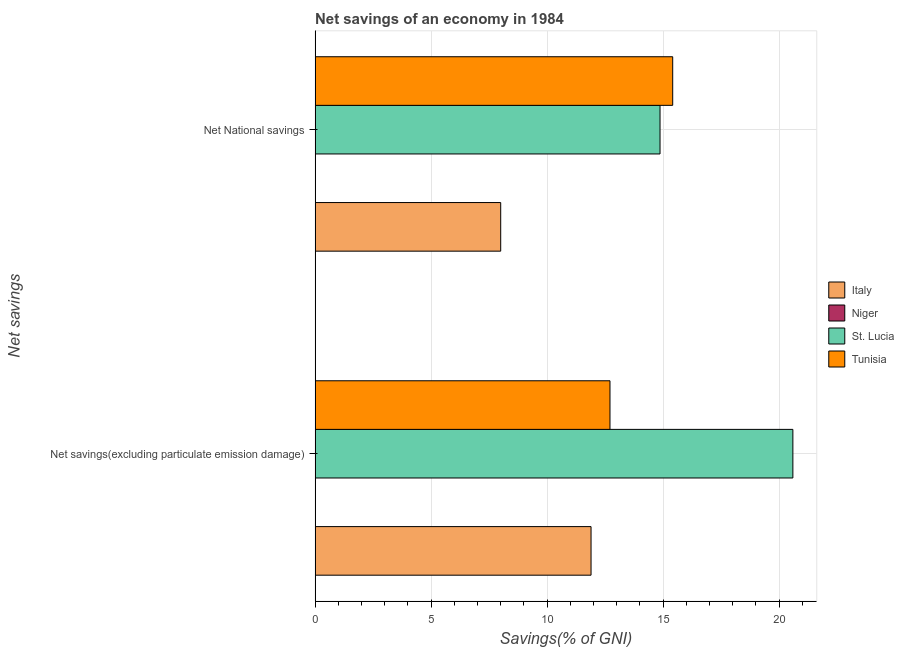How many different coloured bars are there?
Offer a terse response. 3. Are the number of bars per tick equal to the number of legend labels?
Give a very brief answer. No. What is the label of the 2nd group of bars from the top?
Your answer should be very brief. Net savings(excluding particulate emission damage). What is the net national savings in St. Lucia?
Provide a short and direct response. 14.87. Across all countries, what is the maximum net national savings?
Provide a succinct answer. 15.42. In which country was the net savings(excluding particulate emission damage) maximum?
Offer a terse response. St. Lucia. What is the total net savings(excluding particulate emission damage) in the graph?
Your response must be concise. 45.2. What is the difference between the net national savings in Tunisia and that in St. Lucia?
Offer a very short reply. 0.55. What is the difference between the net national savings in Italy and the net savings(excluding particulate emission damage) in Tunisia?
Your response must be concise. -4.71. What is the average net savings(excluding particulate emission damage) per country?
Offer a very short reply. 11.3. What is the difference between the net savings(excluding particulate emission damage) and net national savings in Italy?
Your answer should be compact. 3.89. Is the net savings(excluding particulate emission damage) in Tunisia less than that in Italy?
Your answer should be very brief. No. How many bars are there?
Give a very brief answer. 6. Are all the bars in the graph horizontal?
Give a very brief answer. Yes. What is the difference between two consecutive major ticks on the X-axis?
Your answer should be compact. 5. Are the values on the major ticks of X-axis written in scientific E-notation?
Provide a short and direct response. No. Does the graph contain grids?
Make the answer very short. Yes. How many legend labels are there?
Provide a short and direct response. 4. What is the title of the graph?
Keep it short and to the point. Net savings of an economy in 1984. What is the label or title of the X-axis?
Keep it short and to the point. Savings(% of GNI). What is the label or title of the Y-axis?
Offer a very short reply. Net savings. What is the Savings(% of GNI) in Italy in Net savings(excluding particulate emission damage)?
Keep it short and to the point. 11.9. What is the Savings(% of GNI) in Niger in Net savings(excluding particulate emission damage)?
Your answer should be compact. 0. What is the Savings(% of GNI) in St. Lucia in Net savings(excluding particulate emission damage)?
Provide a short and direct response. 20.6. What is the Savings(% of GNI) of Tunisia in Net savings(excluding particulate emission damage)?
Make the answer very short. 12.71. What is the Savings(% of GNI) in Italy in Net National savings?
Your answer should be compact. 8. What is the Savings(% of GNI) of St. Lucia in Net National savings?
Your response must be concise. 14.87. What is the Savings(% of GNI) of Tunisia in Net National savings?
Provide a succinct answer. 15.42. Across all Net savings, what is the maximum Savings(% of GNI) in Italy?
Make the answer very short. 11.9. Across all Net savings, what is the maximum Savings(% of GNI) of St. Lucia?
Your response must be concise. 20.6. Across all Net savings, what is the maximum Savings(% of GNI) of Tunisia?
Your answer should be very brief. 15.42. Across all Net savings, what is the minimum Savings(% of GNI) of Italy?
Provide a succinct answer. 8. Across all Net savings, what is the minimum Savings(% of GNI) in St. Lucia?
Offer a terse response. 14.87. Across all Net savings, what is the minimum Savings(% of GNI) in Tunisia?
Ensure brevity in your answer.  12.71. What is the total Savings(% of GNI) in Italy in the graph?
Ensure brevity in your answer.  19.9. What is the total Savings(% of GNI) in Niger in the graph?
Provide a short and direct response. 0. What is the total Savings(% of GNI) of St. Lucia in the graph?
Provide a short and direct response. 35.47. What is the total Savings(% of GNI) of Tunisia in the graph?
Give a very brief answer. 28.13. What is the difference between the Savings(% of GNI) in Italy in Net savings(excluding particulate emission damage) and that in Net National savings?
Offer a very short reply. 3.89. What is the difference between the Savings(% of GNI) in St. Lucia in Net savings(excluding particulate emission damage) and that in Net National savings?
Give a very brief answer. 5.73. What is the difference between the Savings(% of GNI) of Tunisia in Net savings(excluding particulate emission damage) and that in Net National savings?
Provide a succinct answer. -2.7. What is the difference between the Savings(% of GNI) in Italy in Net savings(excluding particulate emission damage) and the Savings(% of GNI) in St. Lucia in Net National savings?
Your answer should be very brief. -2.97. What is the difference between the Savings(% of GNI) of Italy in Net savings(excluding particulate emission damage) and the Savings(% of GNI) of Tunisia in Net National savings?
Offer a very short reply. -3.52. What is the difference between the Savings(% of GNI) of St. Lucia in Net savings(excluding particulate emission damage) and the Savings(% of GNI) of Tunisia in Net National savings?
Offer a very short reply. 5.18. What is the average Savings(% of GNI) in Italy per Net savings?
Keep it short and to the point. 9.95. What is the average Savings(% of GNI) of St. Lucia per Net savings?
Offer a very short reply. 17.73. What is the average Savings(% of GNI) of Tunisia per Net savings?
Keep it short and to the point. 14.06. What is the difference between the Savings(% of GNI) in Italy and Savings(% of GNI) in St. Lucia in Net savings(excluding particulate emission damage)?
Your response must be concise. -8.7. What is the difference between the Savings(% of GNI) in Italy and Savings(% of GNI) in Tunisia in Net savings(excluding particulate emission damage)?
Give a very brief answer. -0.82. What is the difference between the Savings(% of GNI) of St. Lucia and Savings(% of GNI) of Tunisia in Net savings(excluding particulate emission damage)?
Make the answer very short. 7.88. What is the difference between the Savings(% of GNI) in Italy and Savings(% of GNI) in St. Lucia in Net National savings?
Ensure brevity in your answer.  -6.87. What is the difference between the Savings(% of GNI) of Italy and Savings(% of GNI) of Tunisia in Net National savings?
Keep it short and to the point. -7.41. What is the difference between the Savings(% of GNI) of St. Lucia and Savings(% of GNI) of Tunisia in Net National savings?
Offer a terse response. -0.55. What is the ratio of the Savings(% of GNI) in Italy in Net savings(excluding particulate emission damage) to that in Net National savings?
Keep it short and to the point. 1.49. What is the ratio of the Savings(% of GNI) in St. Lucia in Net savings(excluding particulate emission damage) to that in Net National savings?
Offer a very short reply. 1.39. What is the ratio of the Savings(% of GNI) of Tunisia in Net savings(excluding particulate emission damage) to that in Net National savings?
Offer a very short reply. 0.82. What is the difference between the highest and the second highest Savings(% of GNI) of Italy?
Your answer should be very brief. 3.89. What is the difference between the highest and the second highest Savings(% of GNI) in St. Lucia?
Keep it short and to the point. 5.73. What is the difference between the highest and the second highest Savings(% of GNI) in Tunisia?
Your answer should be compact. 2.7. What is the difference between the highest and the lowest Savings(% of GNI) in Italy?
Your answer should be very brief. 3.89. What is the difference between the highest and the lowest Savings(% of GNI) in St. Lucia?
Offer a terse response. 5.73. What is the difference between the highest and the lowest Savings(% of GNI) in Tunisia?
Keep it short and to the point. 2.7. 